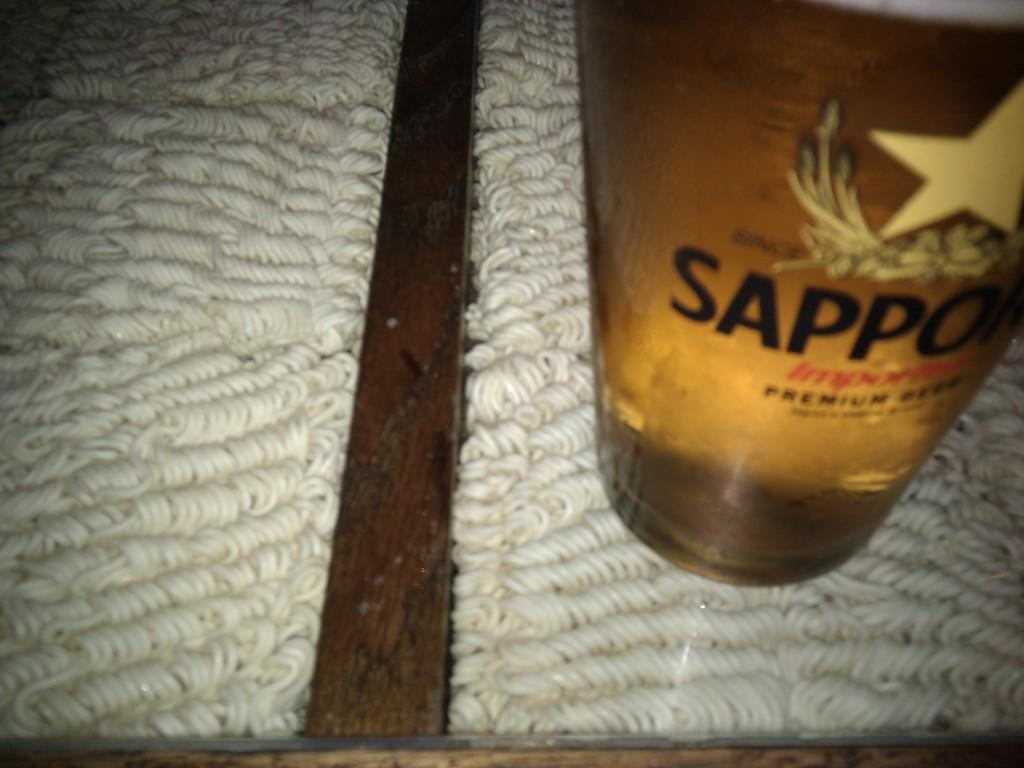<image>
Write a terse but informative summary of the picture. A bottle of Sappo sits on a white cloth 